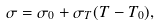Convert formula to latex. <formula><loc_0><loc_0><loc_500><loc_500>\sigma = \sigma _ { 0 } + \sigma _ { T } ( T - T _ { 0 } ) ,</formula> 